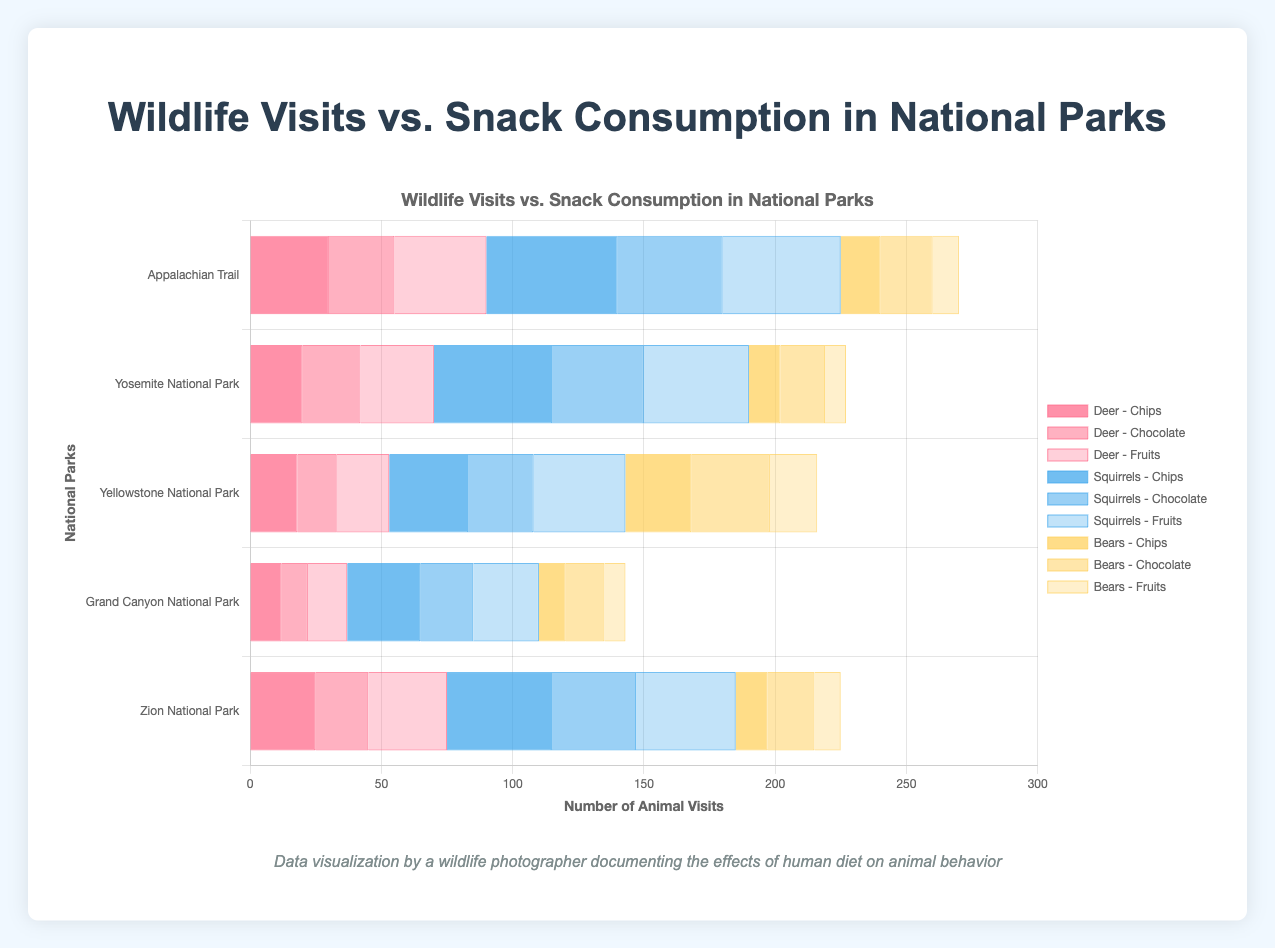Which national park trail has the highest number of deer visits when visitors consume fruits? According to the data in the figure, Appalachian Trail has the highest number of deer visits with 35 when visitors consume fruits.
Answer: Appalachian Trail Which snack type attracts the most squirrels on the Appalachian Trail? By examining the bars for squirrels on the Appalachian Trail, we see that chips attract the most squirrels with a count of 50.
Answer: Chips In which national park trail do bears visit the most with the consumption of chocolate? From the chart, we observe that Yellowstone National Park has the highest number of bear visits with 30 when chocolate is consumed.
Answer: Yellowstone National Park What is the total number of squirrel visits in Yosemite National Park when visitors consume all snack types? Summing up squirrel visits for all snack types in Yosemite National Park gives 45 (Chips) + 35 (Chocolate) + 40 (Fruits) = 120.
Answer: 120 Which animal has the least number of visits in Zion National Park for fruit consumption? According to the figure, bears have the least number of visits with 10 when fruits are consumed in Zion National Park.
Answer: Bears How many more deer visits are there on the Appalachian Trail for fruit consumption compared to chocolate consumption? There are 35 deer visits for fruits and 25 for chocolate on the Appalachian Trail. The difference is 35 - 25 = 10.
Answer: 10 Which trail has the most even distribution of animal visits across all snack types? By visually comparing the bars across trails, Grand Canyon National Park has relatively even distributions of animal visits for each snack type.
Answer: Grand Canyon National Park Do any trails have more bear visits for chips than deer visits? If so, which ones? Inspecting the bear and deer visit bars for chips across all trails, Yellowstone National Park has more bear visits with 25 than deer visits with 18.
Answer: Yellowstone National Park What is the overall average number of squirrel visits on all trails for chocolate consumption? The sum of squirrel visits for chocolate consumption across all trails is 40 (Appalachian) + 35 (Yosemite) + 25 (Yellowstone) + 20 (Grand Canyon) + 32 (Zion) = 152. Dividing by 5 trails gives an average of 152 / 5 = 30.4.
Answer: 30.4 Which animal-visit data points are represented by the blue color in the chart? In the chart, blue represents squirrel visit data points across all snack types and trails.
Answer: Squirrels 